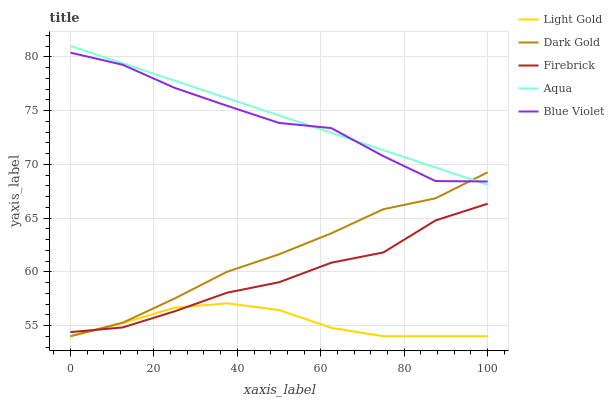Does Light Gold have the minimum area under the curve?
Answer yes or no. Yes. Does Aqua have the maximum area under the curve?
Answer yes or no. Yes. Does Firebrick have the minimum area under the curve?
Answer yes or no. No. Does Firebrick have the maximum area under the curve?
Answer yes or no. No. Is Aqua the smoothest?
Answer yes or no. Yes. Is Blue Violet the roughest?
Answer yes or no. Yes. Is Firebrick the smoothest?
Answer yes or no. No. Is Firebrick the roughest?
Answer yes or no. No. Does Light Gold have the lowest value?
Answer yes or no. Yes. Does Firebrick have the lowest value?
Answer yes or no. No. Does Aqua have the highest value?
Answer yes or no. Yes. Does Firebrick have the highest value?
Answer yes or no. No. Is Firebrick less than Blue Violet?
Answer yes or no. Yes. Is Aqua greater than Firebrick?
Answer yes or no. Yes. Does Firebrick intersect Dark Gold?
Answer yes or no. Yes. Is Firebrick less than Dark Gold?
Answer yes or no. No. Is Firebrick greater than Dark Gold?
Answer yes or no. No. Does Firebrick intersect Blue Violet?
Answer yes or no. No. 